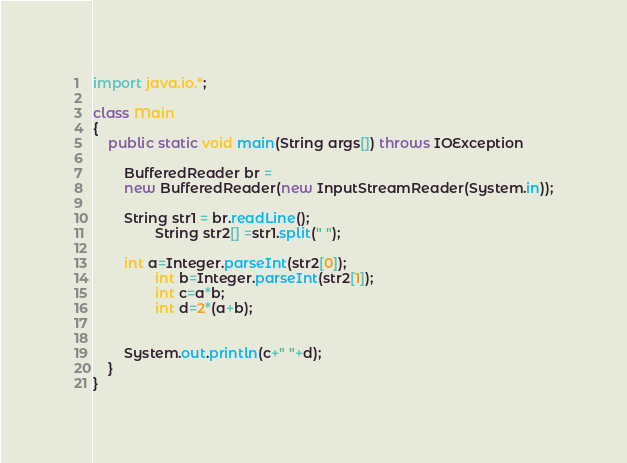<code> <loc_0><loc_0><loc_500><loc_500><_Java_>import java.io.*;

class Main
{
	public static void main(String args[]) throws IOException
	
		BufferedReader br =
		new BufferedReader(new InputStreamReader(System.in));

		String str1 = br.readLine();
                String str2[] =str1.split(" ");
		
		int a=Integer.parseInt(str2[0]);
                int b=Integer.parseInt(str2[1]);
                int c=a*b;
                int d=2*(a+b);


		System.out.println(c+" "+d);
	}
}</code> 